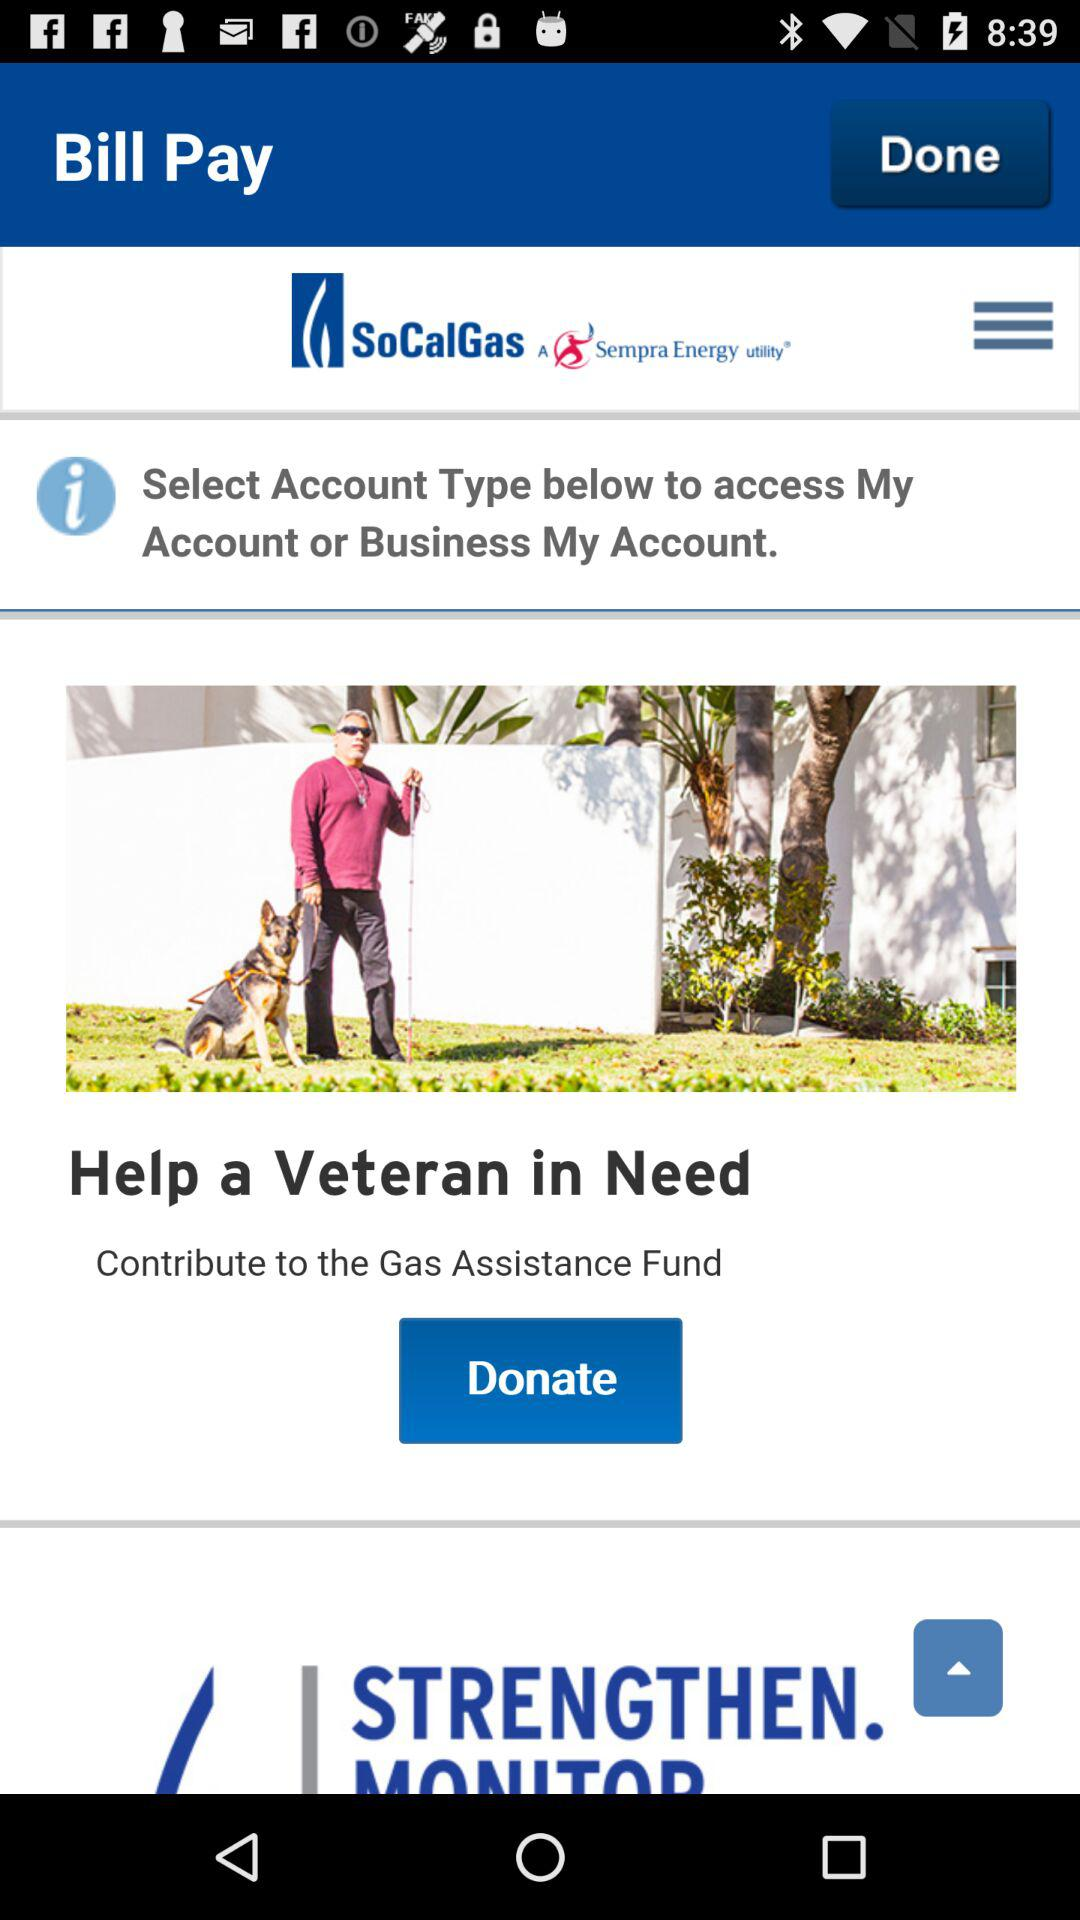What is the application name? The application name is "SoCalGas". 